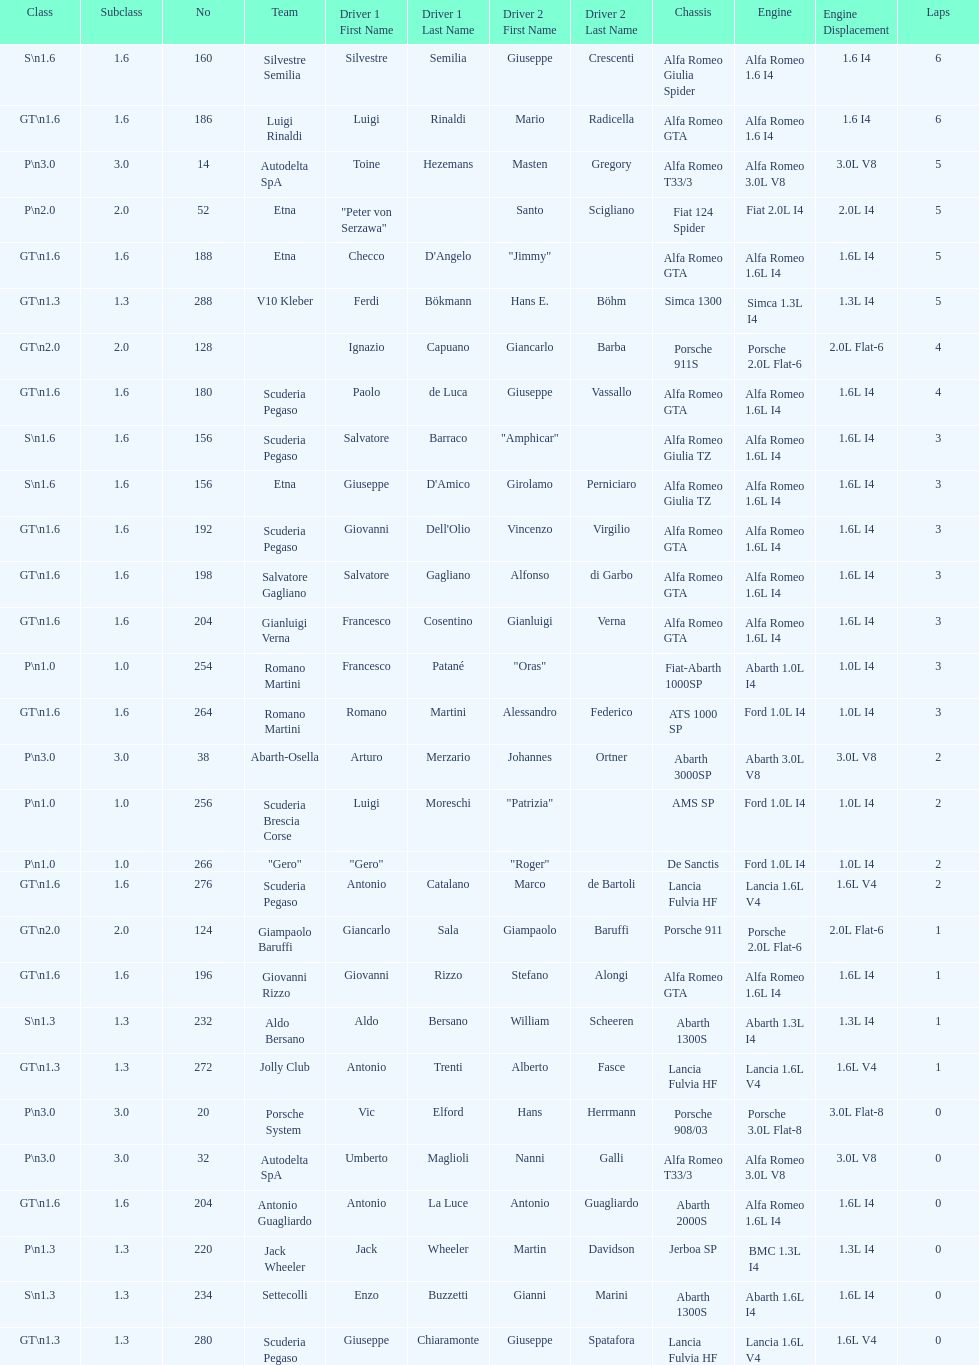How many drivers are from italy? 48. 